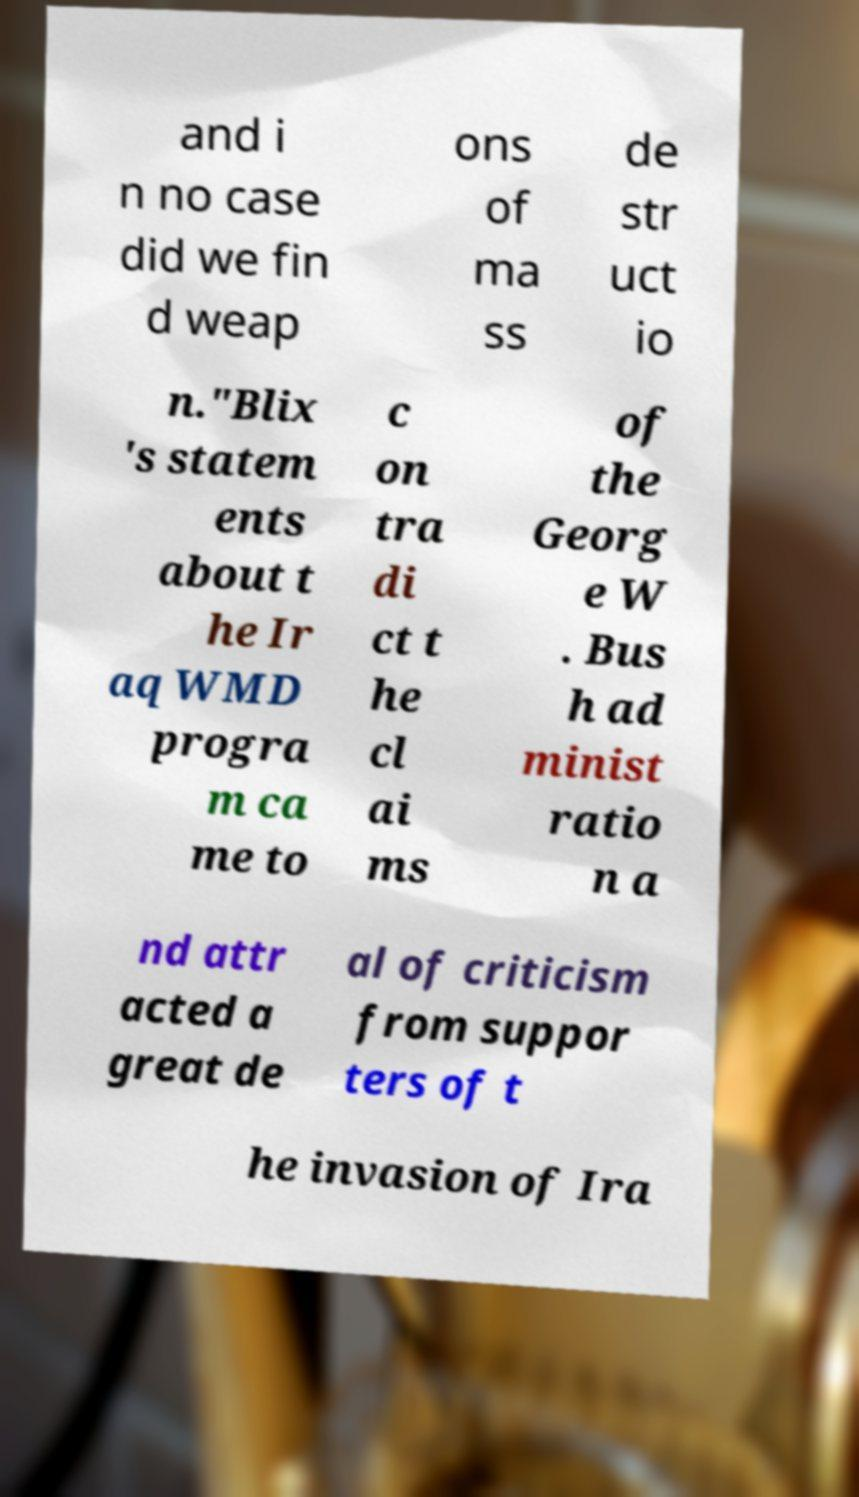I need the written content from this picture converted into text. Can you do that? and i n no case did we fin d weap ons of ma ss de str uct io n."Blix 's statem ents about t he Ir aq WMD progra m ca me to c on tra di ct t he cl ai ms of the Georg e W . Bus h ad minist ratio n a nd attr acted a great de al of criticism from suppor ters of t he invasion of Ira 